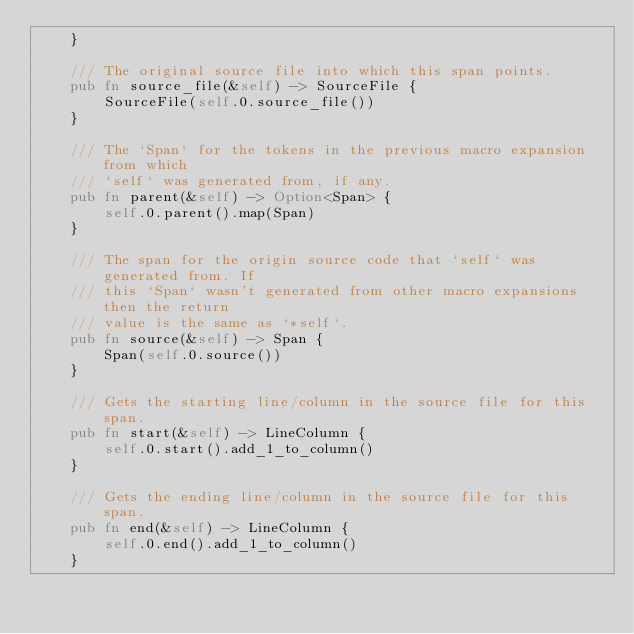<code> <loc_0><loc_0><loc_500><loc_500><_Rust_>    }

    /// The original source file into which this span points.
    pub fn source_file(&self) -> SourceFile {
        SourceFile(self.0.source_file())
    }

    /// The `Span` for the tokens in the previous macro expansion from which
    /// `self` was generated from, if any.
    pub fn parent(&self) -> Option<Span> {
        self.0.parent().map(Span)
    }

    /// The span for the origin source code that `self` was generated from. If
    /// this `Span` wasn't generated from other macro expansions then the return
    /// value is the same as `*self`.
    pub fn source(&self) -> Span {
        Span(self.0.source())
    }

    /// Gets the starting line/column in the source file for this span.
    pub fn start(&self) -> LineColumn {
        self.0.start().add_1_to_column()
    }

    /// Gets the ending line/column in the source file for this span.
    pub fn end(&self) -> LineColumn {
        self.0.end().add_1_to_column()
    }
</code> 